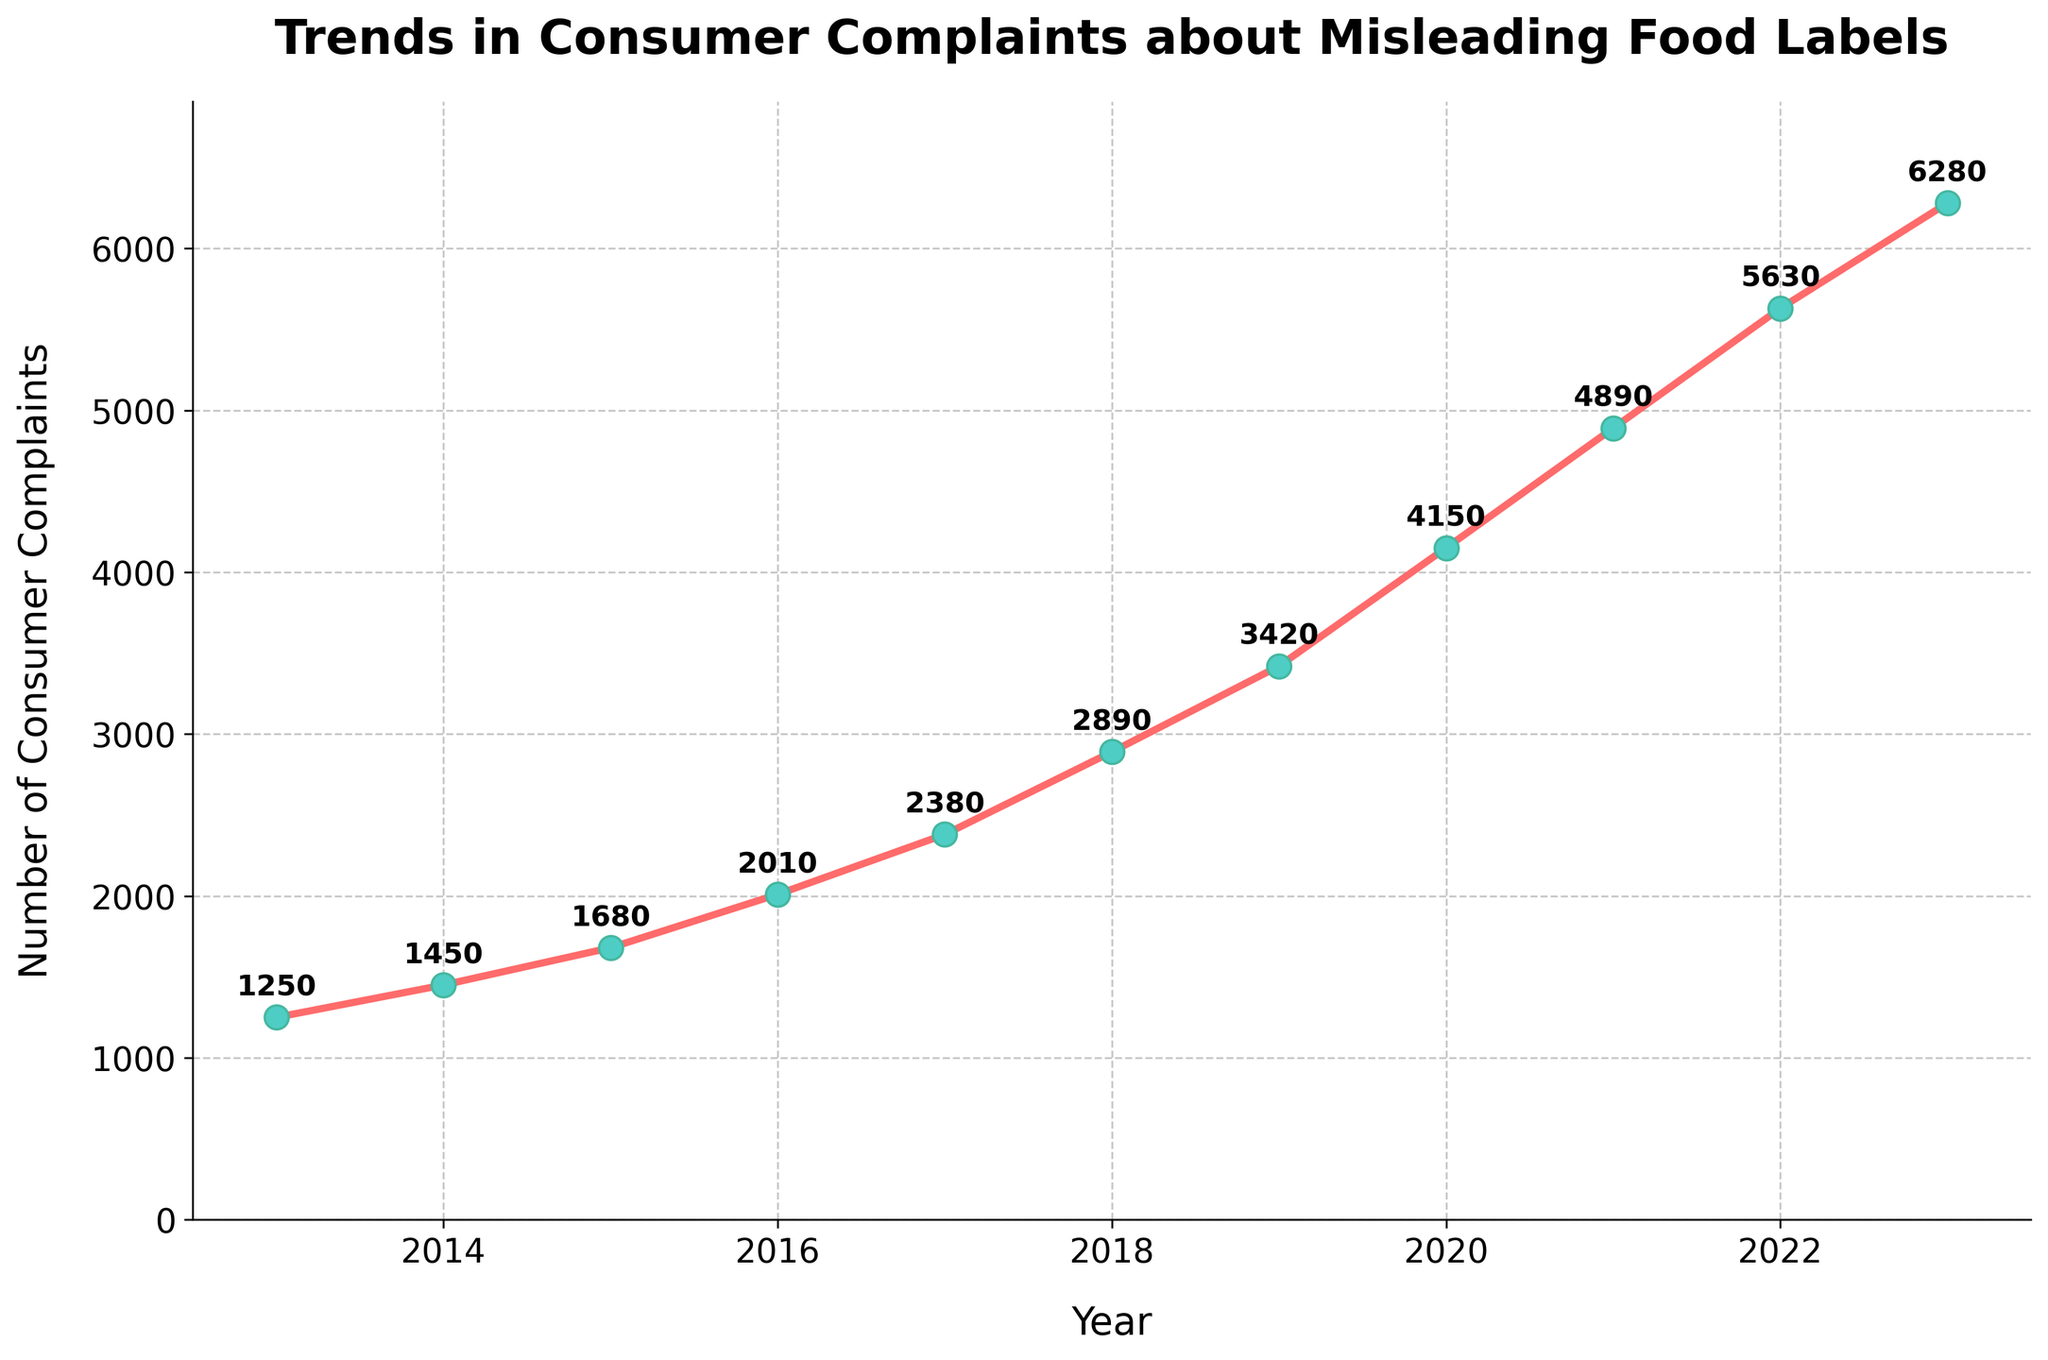What is the total number of consumer complaints from 2013 to 2023? Sum the number of consumer complaints for each year from 2013 to 2023: 1250 + 1450 + 1680 + 2010 + 2380 + 2890 + 3420 + 4150 + 4890 + 5630 + 6280 = 36030
Answer: 36030 Which year saw the highest number of consumer complaints? Look at the data points for each year and identify the highest value. The highest value is 6280 and corresponds to the year 2023.
Answer: 2023 What is the increase in the number of consumer complaints from 2013 to 2023? Subtract the number of complaints in 2013 (1250) from the number in 2023 (6280): 6280 - 1250 = 5030
Answer: 5030 How many more complaints were there in 2020 compared to 2015? Subtract the number of complaints in 2015 (1680) from the number in 2020 (4150): 4150 - 1680 = 2470
Answer: 2470 What is the average number of consumer complaints over the decade? Sum the number of complaints each year and divide by the total number of years (11): (1250 + 1450 + 1680 + 2010 + 2380 + 2890 + 3420 + 4150 + 4890 + 5630 + 6280) / 11 ≈ 3275.45
Answer: 3275.45 Did the number of consumer complaints ever decrease year-over-year from 2013 to 2023? Observe the plot or data points. Every year, the number of complaints increased compared to the previous year. Thus, there was no decrease year-over-year.
Answer: No In which period (year) did the number of consumer complaints experience the largest year-over-year increase? Calculate the year-over-year increase for each period and find the maximum one. From visual inspection or computation: the largest increase is from 2019 to 2020, which is 4150 - 3420 = 730.
Answer: 2019 to 2020 What is the median number of consumer complaints over the past decade? Observe the number of complaints for each year, sort them, and find the middle value. The sorted list is: [1250, 1450, 1680, 2010, 2380, 2890, 3420, 4150, 4890, 5630, 6280]. The median is the middle value: 2890
Answer: 2890 